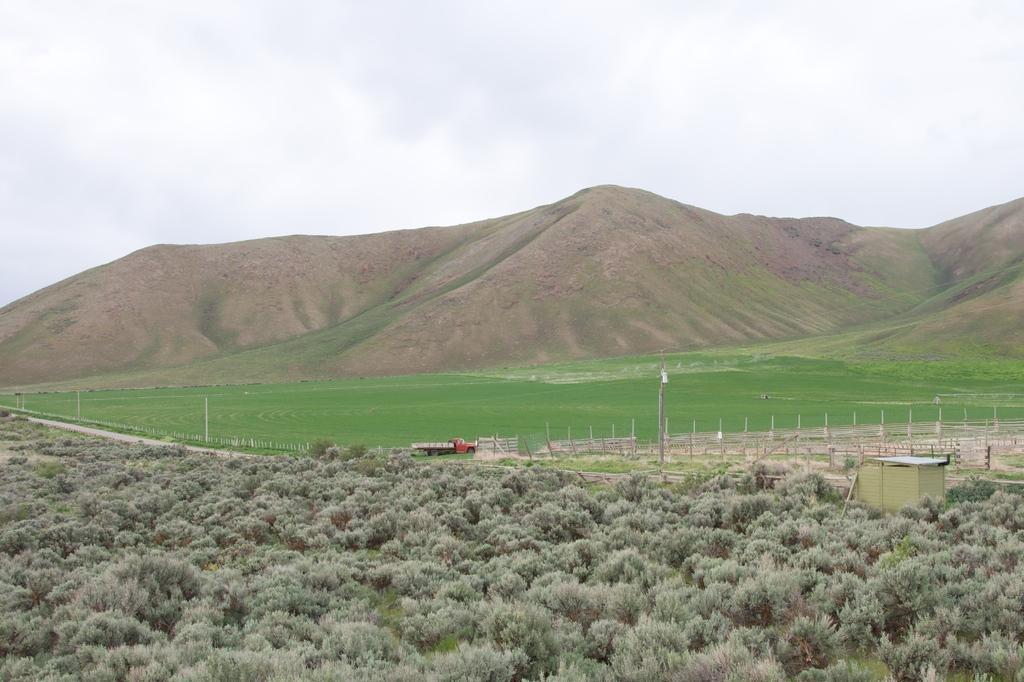Please provide a concise description of this image. In this picture I can see there is a truck moving and there is grass, plants and trees and there is a mountain in the backdrop and the sky is clear. 